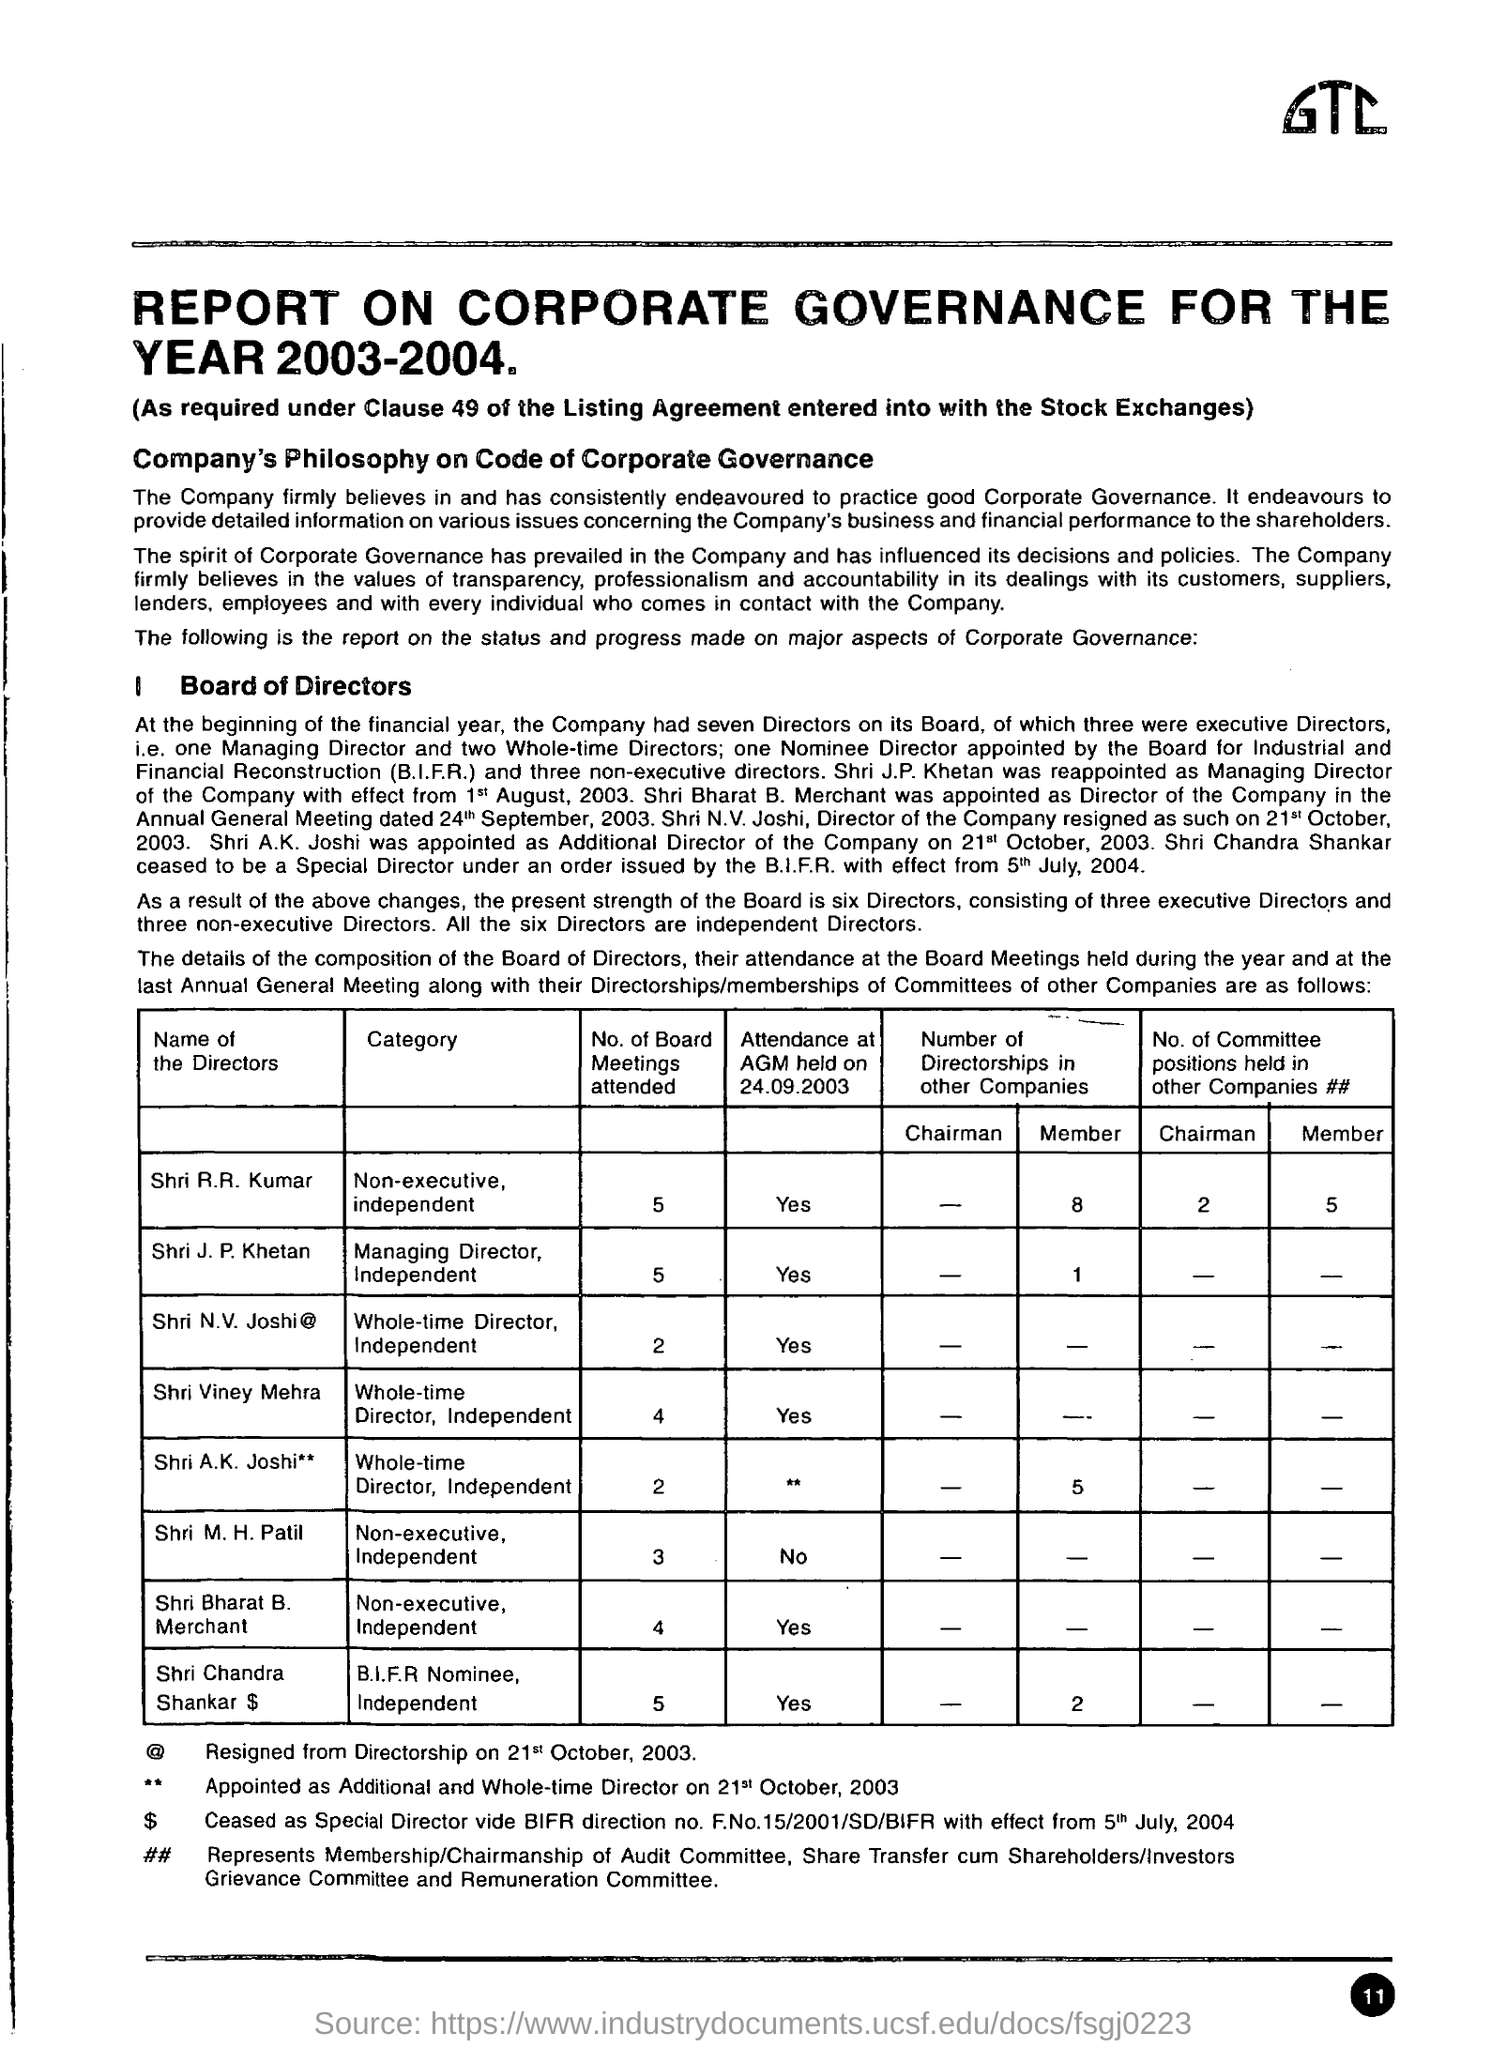At the beginning of the financial year  how many directors company had
 seven 